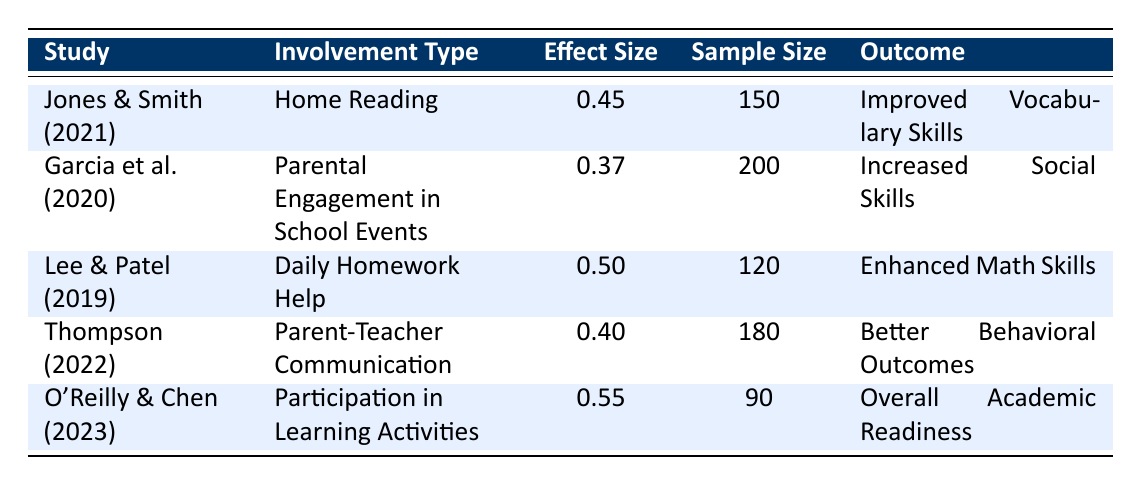What is the effect size of "Home Reading" involvement? The table lists "Home Reading" under the involvement type with an effect size of 0.45.
Answer: 0.45 Which study shows the highest effect size? By comparing the effect sizes in the table, "Participation in Learning Activities" from O'Reilly & Chen (2023) has the highest effect size of 0.55.
Answer: O'Reilly & Chen (2023) Is the sample size for "Daily Homework Help" larger than 150? The sample size for "Daily Homework Help" is 120, which is less than 150.
Answer: No What are the outcomes for studies with effect sizes above 0.4? The studies with effect sizes above 0.4 are: "Home Reading" (Improved Vocabulary Skills), "Daily Homework Help" (Enhanced Math Skills), "Parent-Teacher Communication" (Better Behavioral Outcomes), and "Participation in Learning Activities" (Overall Academic Readiness).
Answer: Improved Vocabulary Skills, Enhanced Math Skills, Better Behavioral Outcomes, Overall Academic Readiness What is the average effect size for the studies? Adding the effect sizes: 0.45 + 0.37 + 0.50 + 0.40 + 0.55 = 2.27. Dividing by the number of studies (5) gives an average of 2.27 / 5 = 0.454.
Answer: 0.454 Which study focuses on "Parental Engagement in School Events" and what is its effect size? "Parental Engagement in School Events" is addressed in the study by Garcia et al. (2020) with an effect size of 0.37.
Answer: Garcia et al. (2020), 0.37 Is there at least one study that reports an outcome related to social skills? Yes, the study by Garcia et al. (2020) reports an outcome of increased social skills.
Answer: Yes Which involvement type was investigated by Thompson in 2022? The table shows that Thompson (2022) investigated "Parent-Teacher Communication."
Answer: Parent-Teacher Communication 